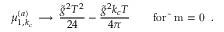Convert formula to latex. <formula><loc_0><loc_0><loc_500><loc_500>\mu _ { 1 , k _ { c } } ^ { ( a ) } \, \longrightarrow \, { \frac { \tilde { g } ^ { 2 } T ^ { 2 } } { 2 4 } } - { \frac { \tilde { g } ^ { 2 } k _ { c } T } { 4 \pi } } \quad f o r m = 0 \, .</formula> 